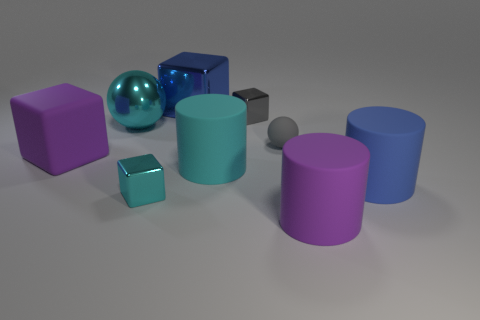What colors are the spheres in the image? There are two spheres in the image. One is turquoise and the other is a reflective surface that seems to be mirroring the surrounding colors, predominantly showing shades of gray. 